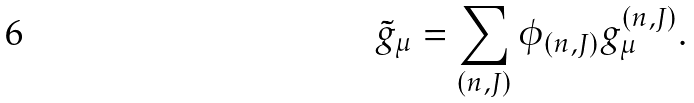Convert formula to latex. <formula><loc_0><loc_0><loc_500><loc_500>\tilde { g } _ { \mu } = \sum _ { ( n , J ) } \phi _ { ( n , J ) } g ^ { ( n , J ) } _ { \mu } .</formula> 